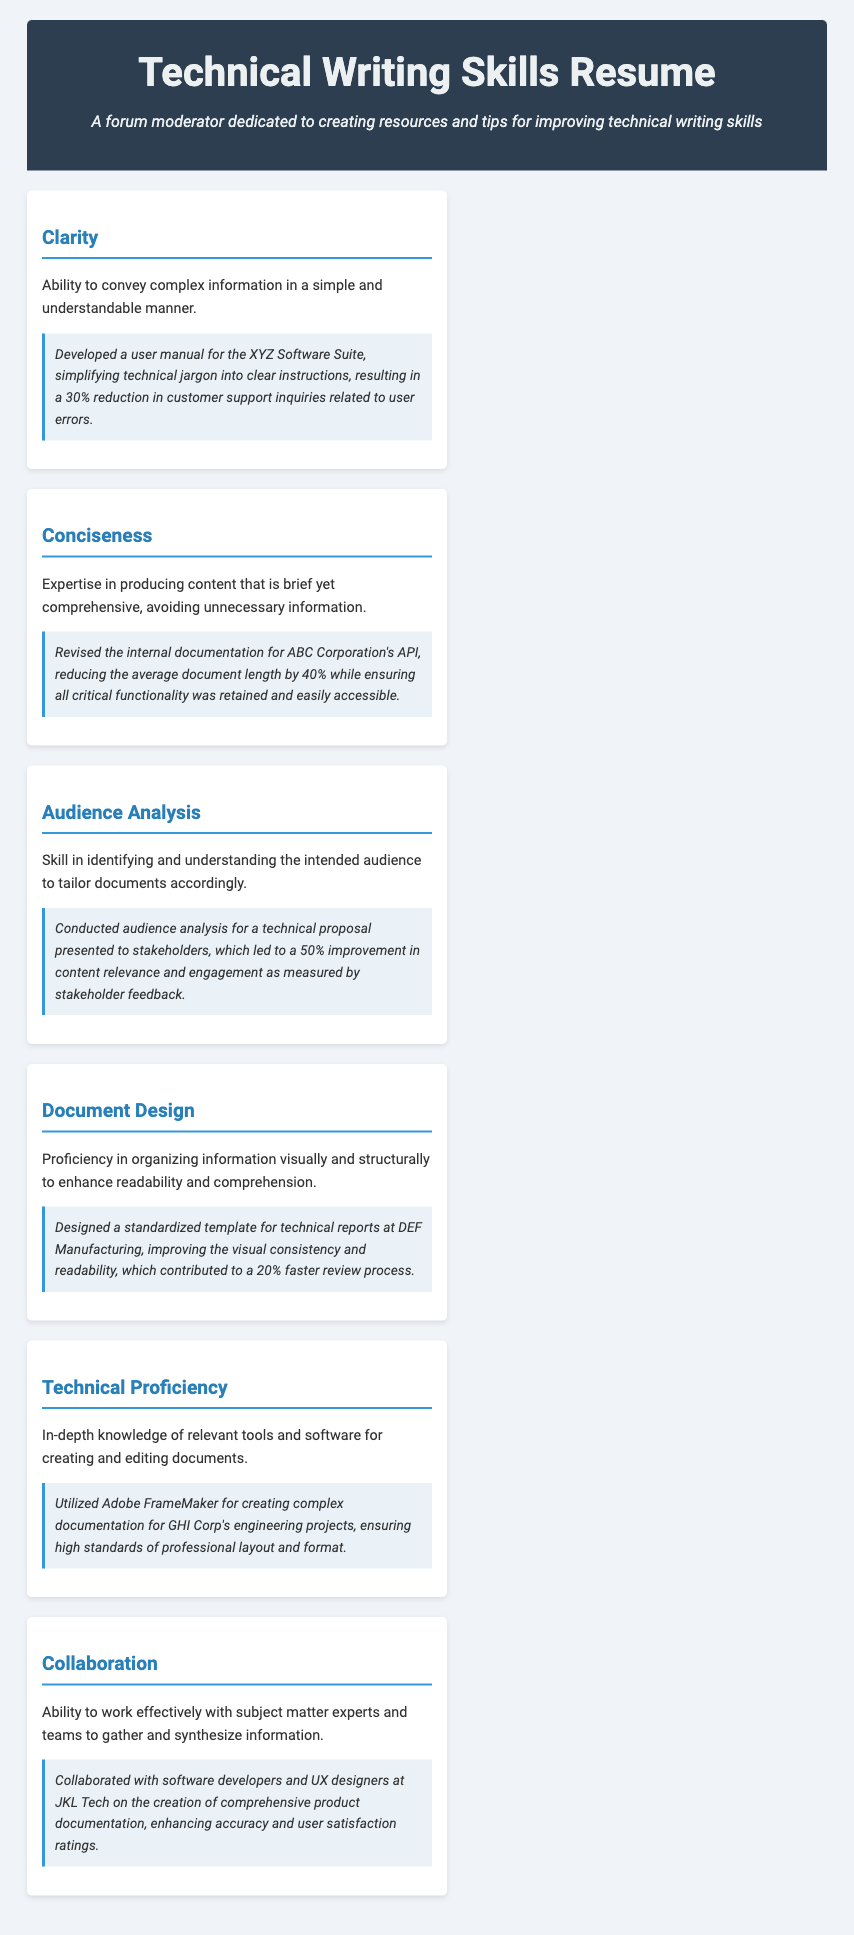what is the title of the document? The title is mentioned in the header section of the document, which is "Technical Writing Skills Resume."
Answer: Technical Writing Skills Resume how many skills are highlighted in the document? The document lists six skills in the skills section.
Answer: 6 what was the outcome of developing the user manual for the XYZ Software Suite? The document states that the user's manual development resulted in a 30% reduction in customer support inquiries related to user errors.
Answer: 30% what software was used for creating documentation at GHI Corp? The document specifies that Adobe FrameMaker was utilized for creating complex documentation.
Answer: Adobe FrameMaker which skill focuses on organizing information visually? The skill card related to this is titled "Document Design."
Answer: Document Design what percentage improvement in content relevance was achieved through audience analysis? The document indicates a 50% improvement in content relevance and engagement after conducting audience analysis.
Answer: 50% who collaborated on the creation of comprehensive product documentation at JKL Tech? The collaboration involved software developers and UX designers.
Answer: software developers and UX designers by what percentage was the average document length reduced when revising internal documentation for ABC Corporation's API? The document states that the average document length was reduced by 40%.
Answer: 40% what is the subtitle of the document? The subtitle is "A forum moderator dedicated to creating resources and tips for improving technical writing skills."
Answer: A forum moderator dedicated to creating resources and tips for improving technical writing skills 